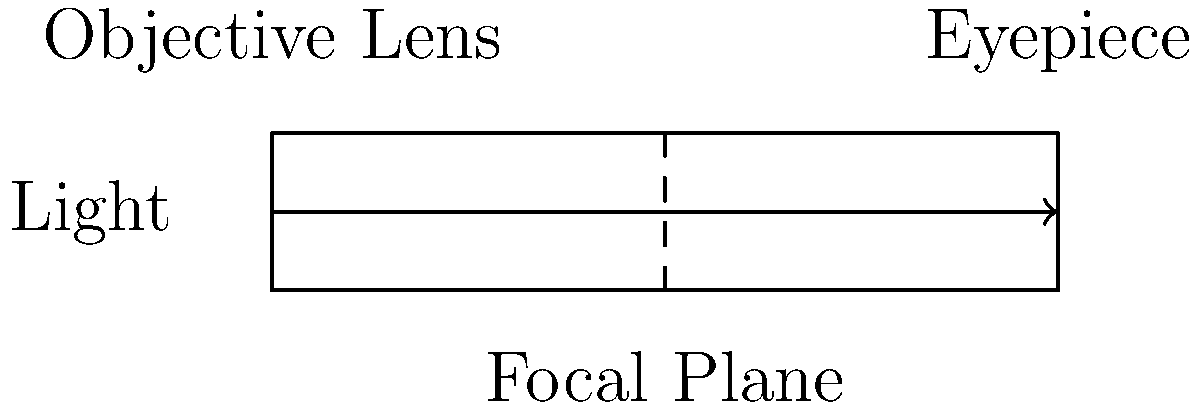In the context of innovative marketing for telescope manufacturers, which component of a refracting telescope is responsible for gathering and focusing light from distant objects, and how does this relate to the telescope's overall magnification power? To understand the relationship between telescope components and magnification, let's break down the structure of a refracting telescope:

1. Objective Lens: This is the large lens at the front of the telescope. It gathers light from distant objects and focuses it to create an image.

2. Focal Plane: This is where the image formed by the objective lens comes to a focus.

3. Eyepiece: This is the lens through which the observer looks. It magnifies the image formed by the objective lens.

The objective lens is responsible for gathering and focusing light. Its size (aperture) determines how much light the telescope can collect, which affects the brightness and detail of the image.

The magnification of a telescope is calculated by dividing the focal length of the objective lens by the focal length of the eyepiece:

$$ \text{Magnification} = \frac{\text{Focal Length of Objective}}{\text{Focal Length of Eyepiece}} $$

Therefore, while the objective lens doesn't directly determine magnification, its focal length is crucial in the magnification calculation.

From a marketing perspective, emphasizing the quality and size of the objective lens can be a key selling point, as it directly impacts the telescope's light-gathering ability and indirectly affects its potential magnification range.
Answer: Objective lens 